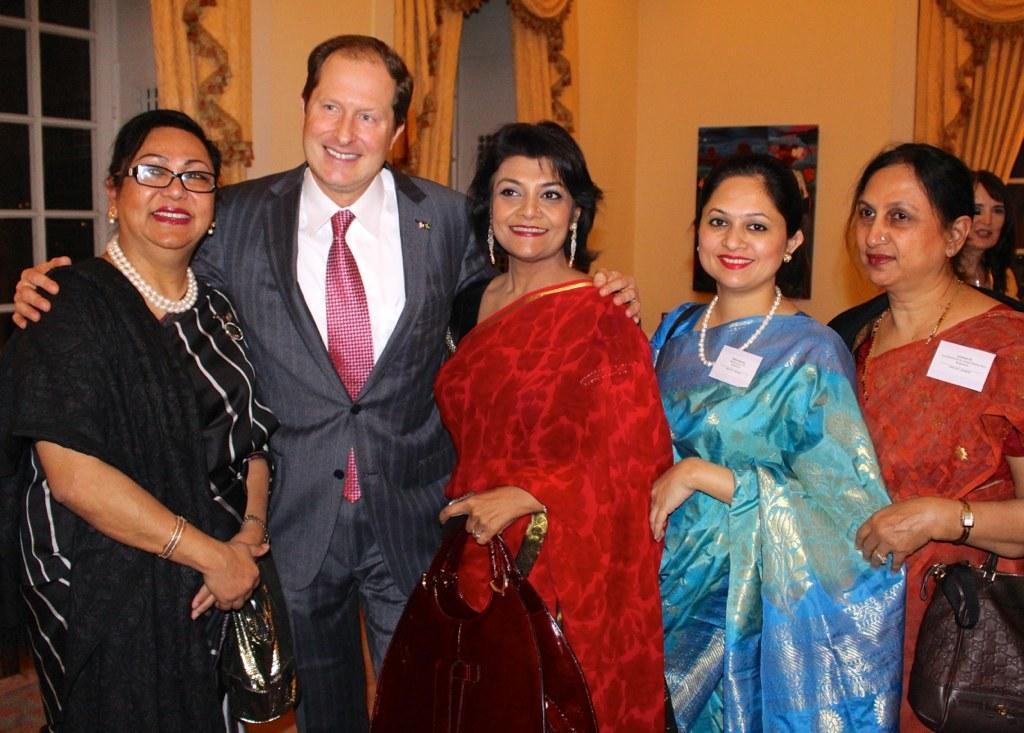Please provide a concise description of this image. On the left side, there is a person in a suit, placing both hands on the two women who are on sides of him. On the right side, there are other two women with saree, smiling and standing. In the background, there is another woman, there are windows having curtains and there is a painting attached to the wall. 